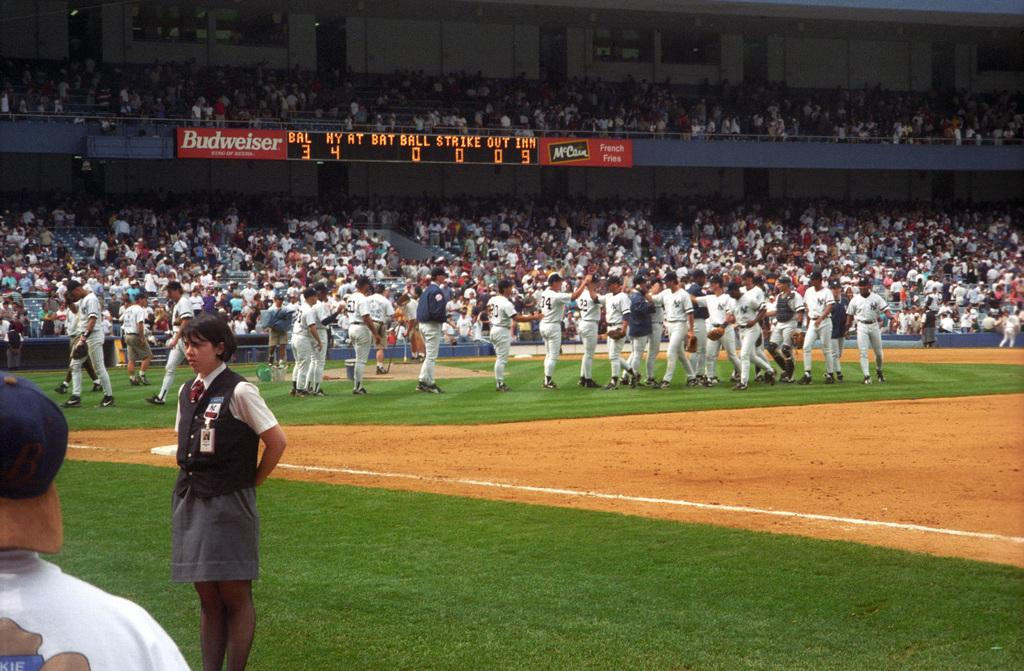<image>
Provide a brief description of the given image. the Budweiser sign is next to the score board 